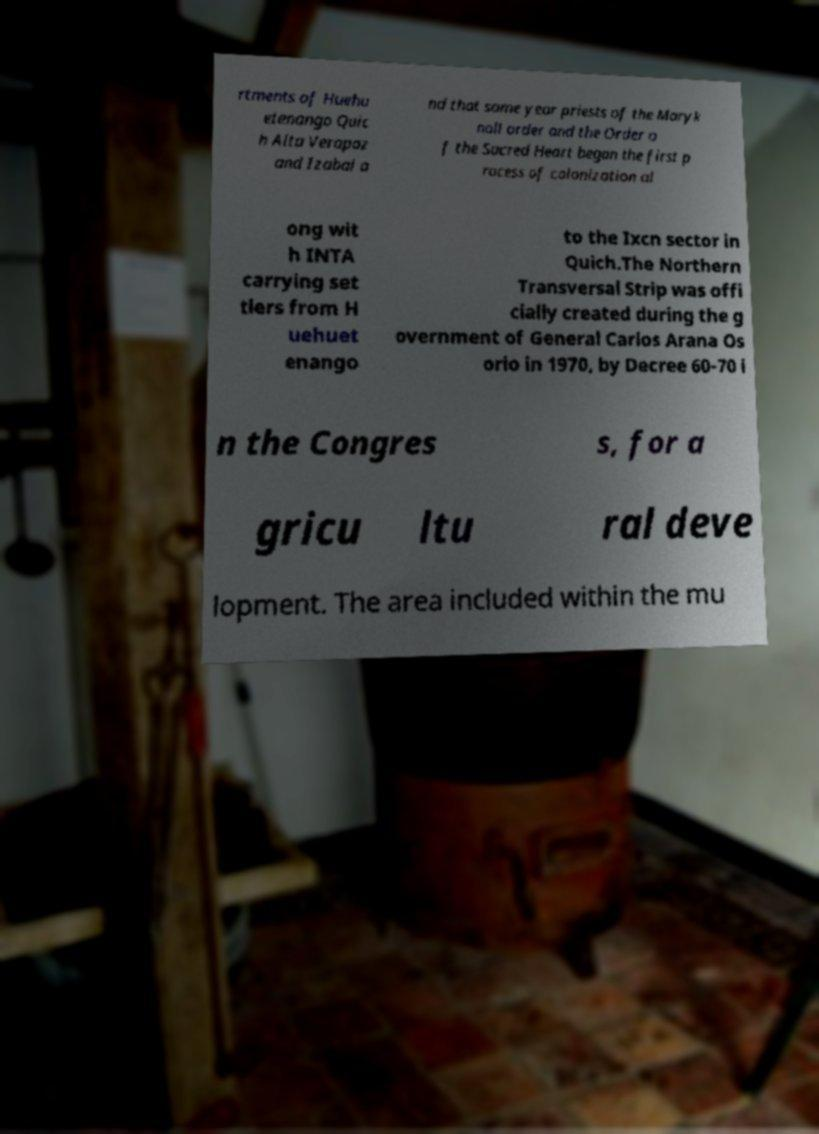Could you assist in decoding the text presented in this image and type it out clearly? rtments of Huehu etenango Quic h Alta Verapaz and Izabal a nd that same year priests of the Maryk noll order and the Order o f the Sacred Heart began the first p rocess of colonization al ong wit h INTA carrying set tlers from H uehuet enango to the Ixcn sector in Quich.The Northern Transversal Strip was offi cially created during the g overnment of General Carlos Arana Os orio in 1970, by Decree 60-70 i n the Congres s, for a gricu ltu ral deve lopment. The area included within the mu 